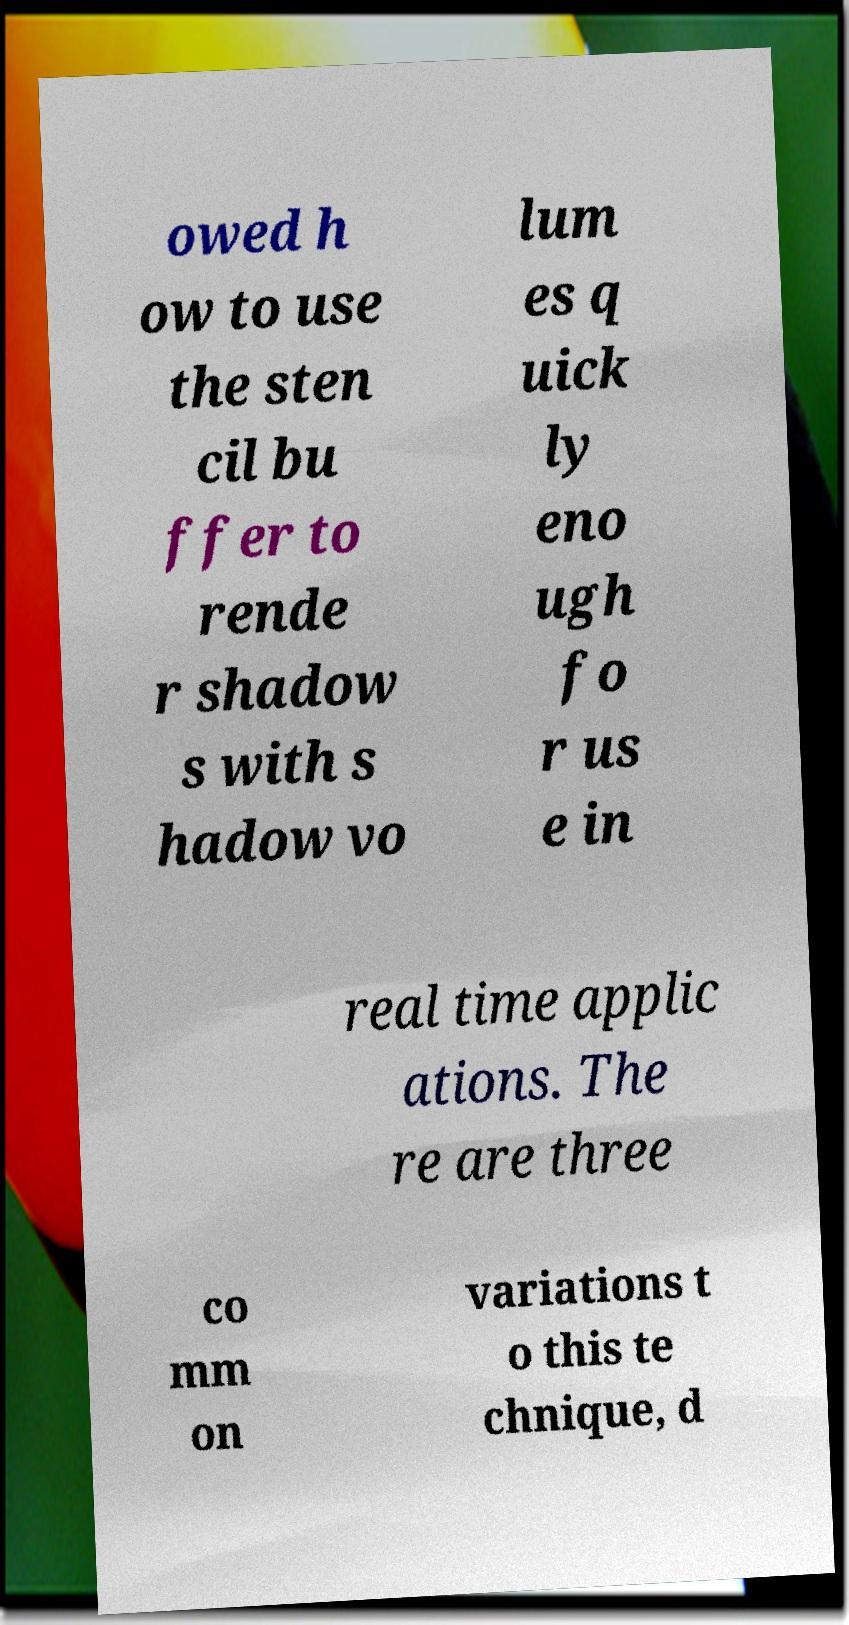There's text embedded in this image that I need extracted. Can you transcribe it verbatim? owed h ow to use the sten cil bu ffer to rende r shadow s with s hadow vo lum es q uick ly eno ugh fo r us e in real time applic ations. The re are three co mm on variations t o this te chnique, d 